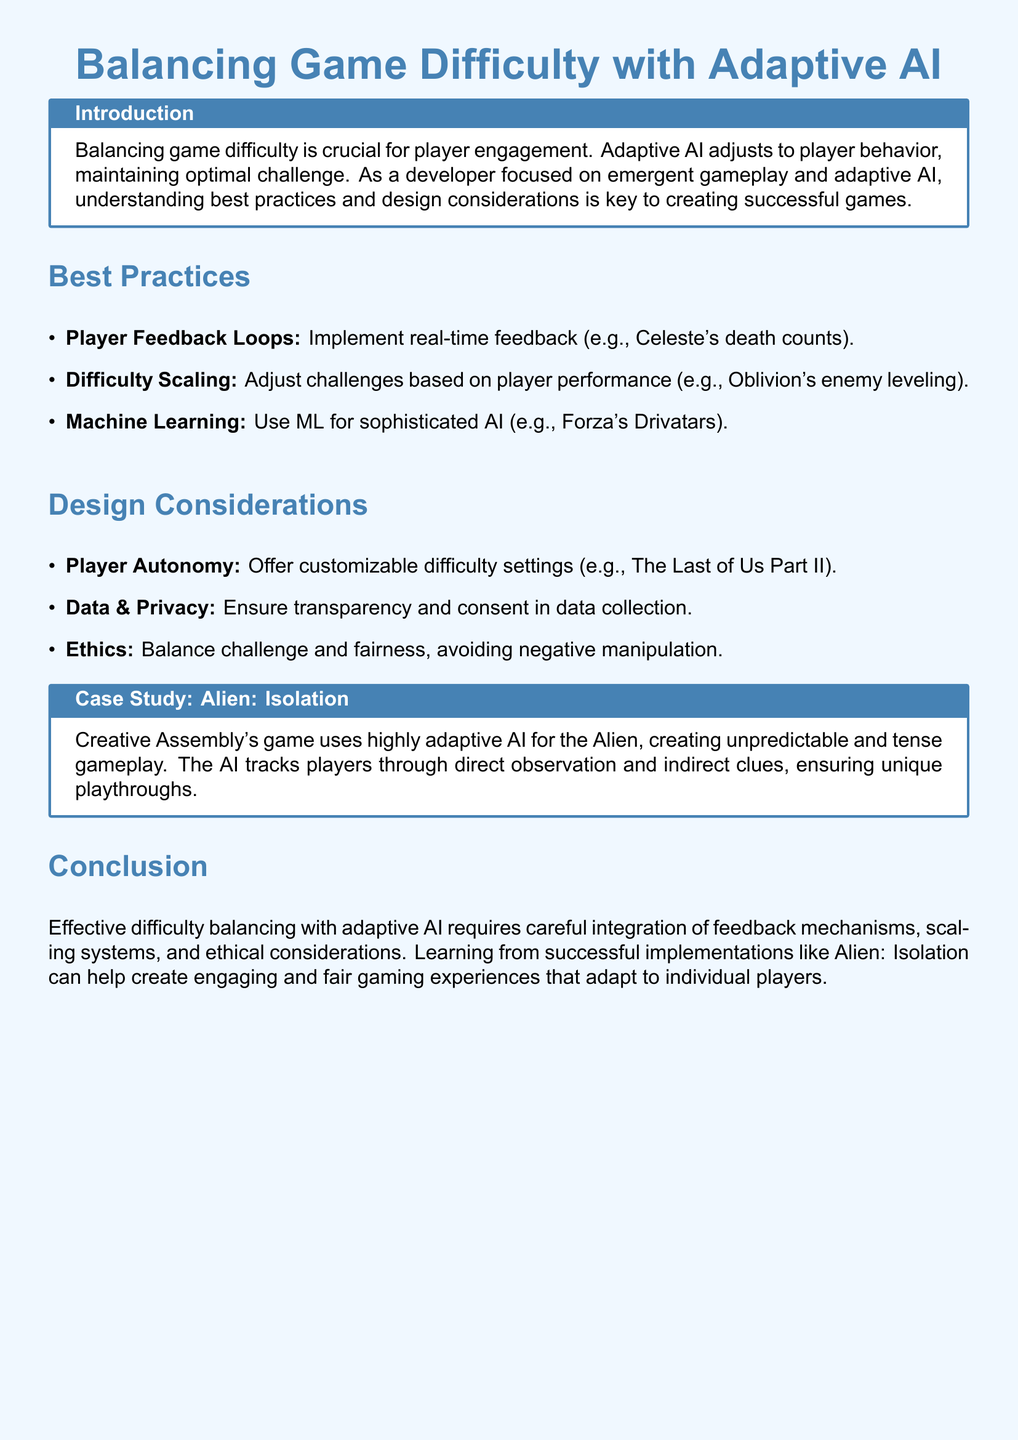What is the title of the document? The title of the document, as stated in the introduction, is Balancing Game Difficulty with Adaptive AI.
Answer: Balancing Game Difficulty with Adaptive AI What is an example of a feedback mechanism mentioned? The document provides the example of Celeste's death counts as a real-time feedback mechanism.
Answer: Celeste's death counts What does Adaptive AI help to maintain? The purpose of Adaptive AI is to maintain optimal challenge for players within the game.
Answer: Optimal challenge What is one ethical consideration highlighted in the document? The document mentions avoiding negative manipulation as an important ethical consideration in game design.
Answer: Negative manipulation Which game is cited as using customizable difficulty settings? The Last of Us Part II is identified as a game that offers customizable difficulty settings.
Answer: The Last of Us Part II What type of AI does the case study on Alien: Isolation focus on? The case study discusses highly adaptive AI as a central feature of Alien: Isolation.
Answer: Highly adaptive AI How does Alien: Isolation's AI track players? The AI in Alien: Isolation tracks players through direct observation and indirect clues.
Answer: Direct observation and indirect clues What is a use of machine learning in games mentioned? The document cites Forza's Drivatars as an example of machine learning used for sophisticated AI.
Answer: Forza's Drivatars What is the main purpose of the document? This document aims to explore best practices and design considerations for balancing game difficulty with adaptive AI.
Answer: Explore best practices and design considerations 